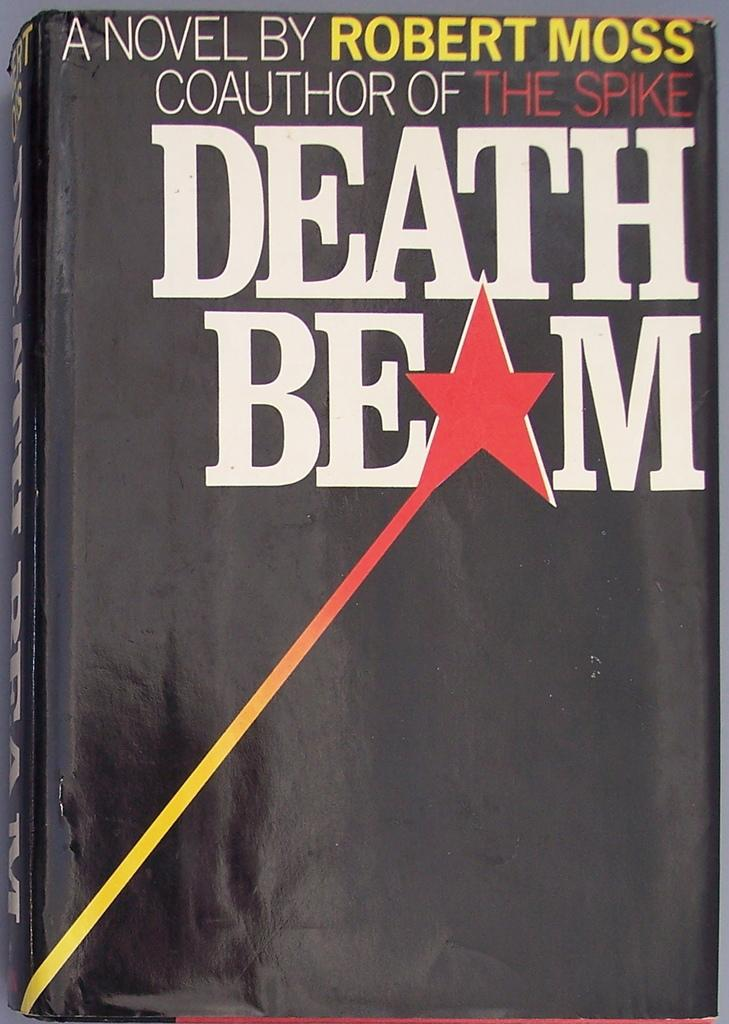Provide a one-sentence caption for the provided image. Death Beam chapter book by robert moss who is the coauthor of the spike. 